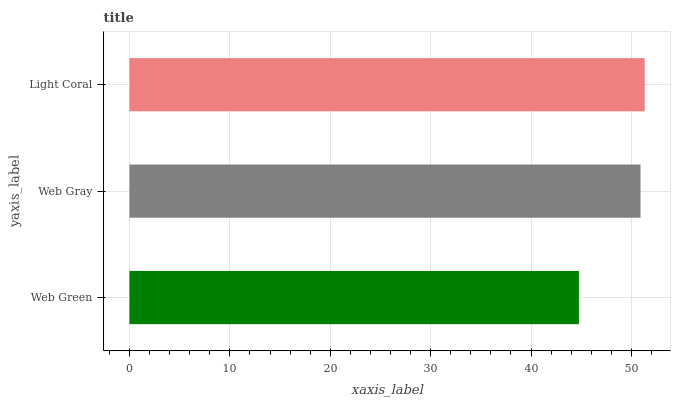Is Web Green the minimum?
Answer yes or no. Yes. Is Light Coral the maximum?
Answer yes or no. Yes. Is Web Gray the minimum?
Answer yes or no. No. Is Web Gray the maximum?
Answer yes or no. No. Is Web Gray greater than Web Green?
Answer yes or no. Yes. Is Web Green less than Web Gray?
Answer yes or no. Yes. Is Web Green greater than Web Gray?
Answer yes or no. No. Is Web Gray less than Web Green?
Answer yes or no. No. Is Web Gray the high median?
Answer yes or no. Yes. Is Web Gray the low median?
Answer yes or no. Yes. Is Light Coral the high median?
Answer yes or no. No. Is Light Coral the low median?
Answer yes or no. No. 